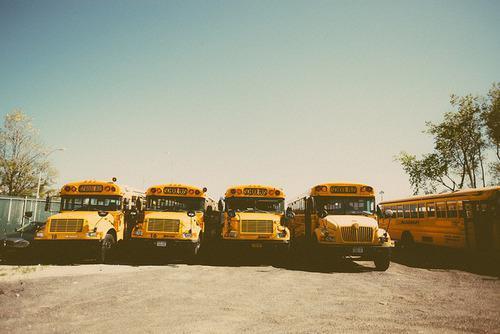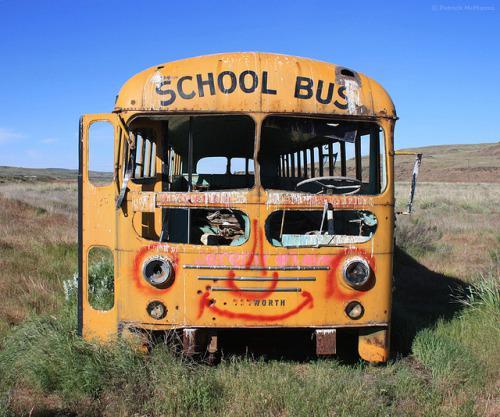The first image is the image on the left, the second image is the image on the right. For the images displayed, is the sentence "The photo on the right shows a school bus that has been painted, while the image on the left shows a row of at least five school buses." factually correct? Answer yes or no. Yes. The first image is the image on the left, the second image is the image on the right. Evaluate the accuracy of this statement regarding the images: "One of the busses has graffiti on it.". Is it true? Answer yes or no. Yes. 